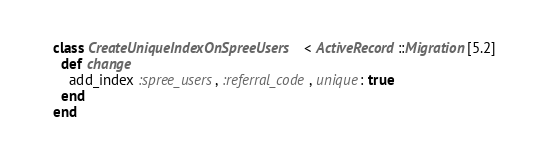Convert code to text. <code><loc_0><loc_0><loc_500><loc_500><_Ruby_>class CreateUniqueIndexOnSpreeUsers < ActiveRecord::Migration[5.2]
  def change
    add_index :spree_users, :referral_code, unique: true
  end
end
</code> 